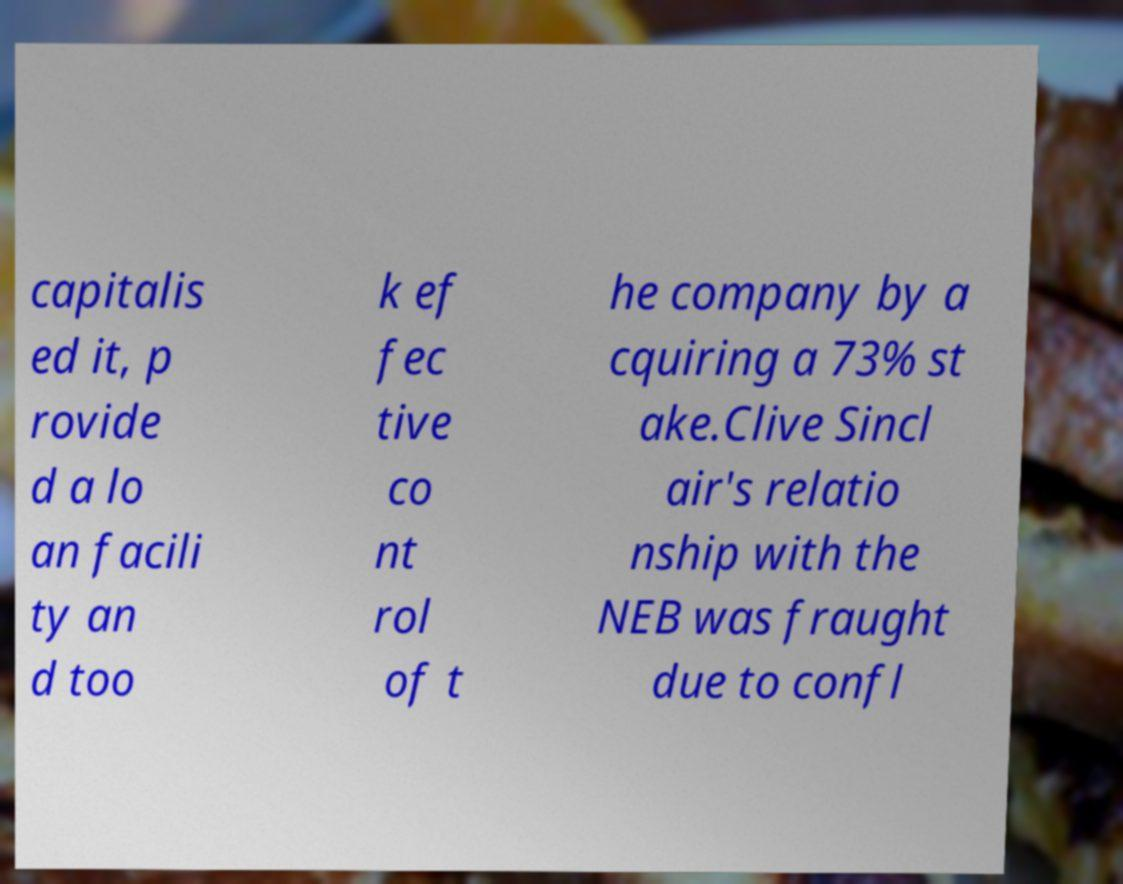Can you read and provide the text displayed in the image?This photo seems to have some interesting text. Can you extract and type it out for me? capitalis ed it, p rovide d a lo an facili ty an d too k ef fec tive co nt rol of t he company by a cquiring a 73% st ake.Clive Sincl air's relatio nship with the NEB was fraught due to confl 